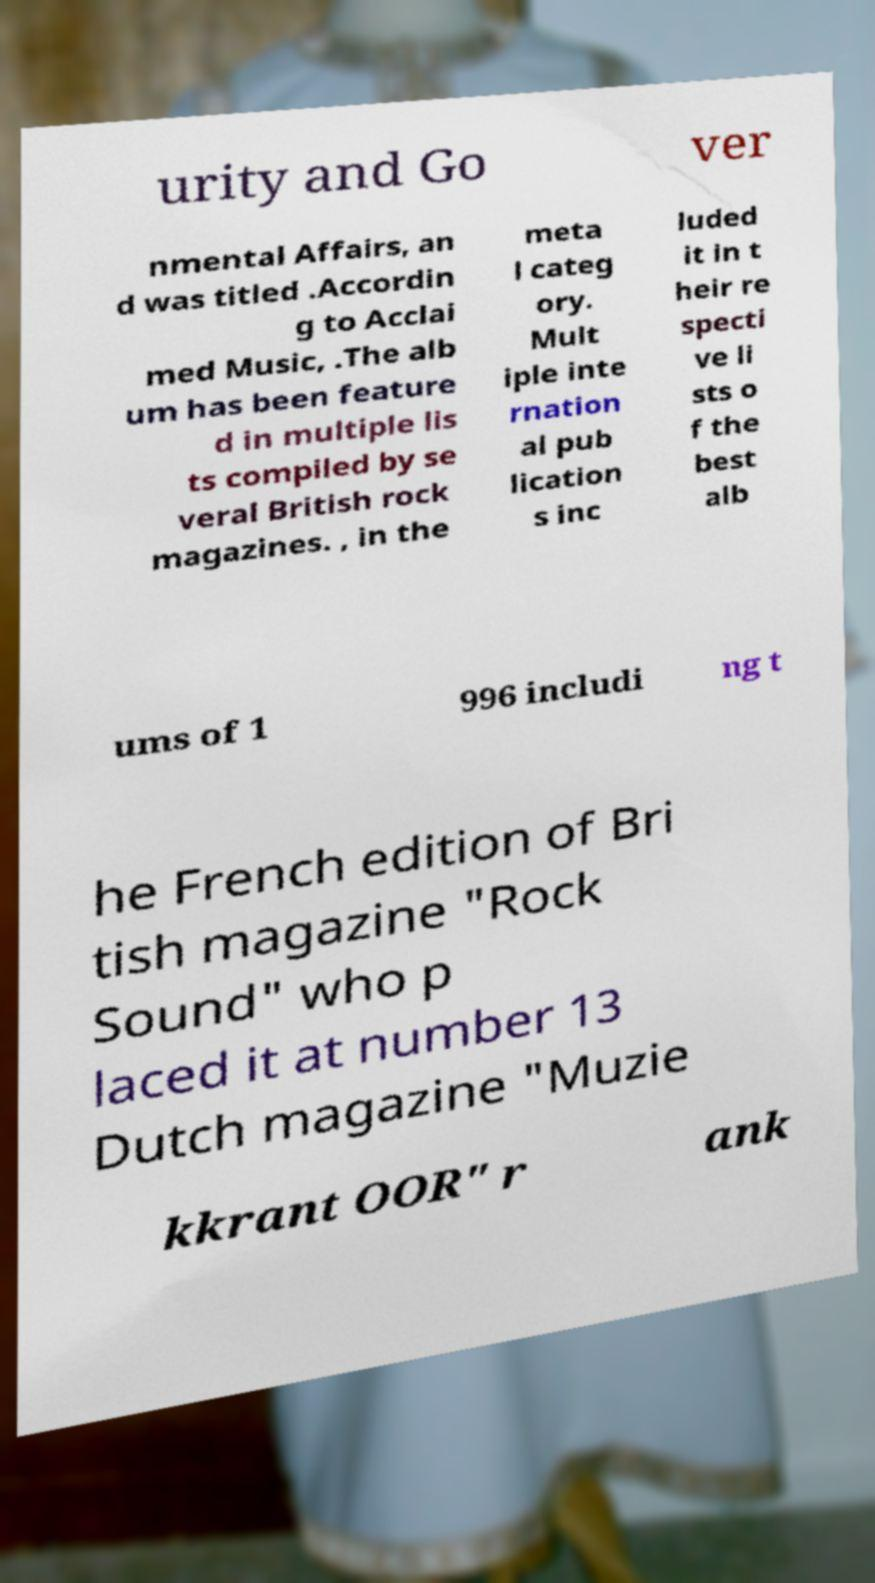Please identify and transcribe the text found in this image. urity and Go ver nmental Affairs, an d was titled .Accordin g to Acclai med Music, .The alb um has been feature d in multiple lis ts compiled by se veral British rock magazines. , in the meta l categ ory. Mult iple inte rnation al pub lication s inc luded it in t heir re specti ve li sts o f the best alb ums of 1 996 includi ng t he French edition of Bri tish magazine "Rock Sound" who p laced it at number 13 Dutch magazine "Muzie kkrant OOR" r ank 